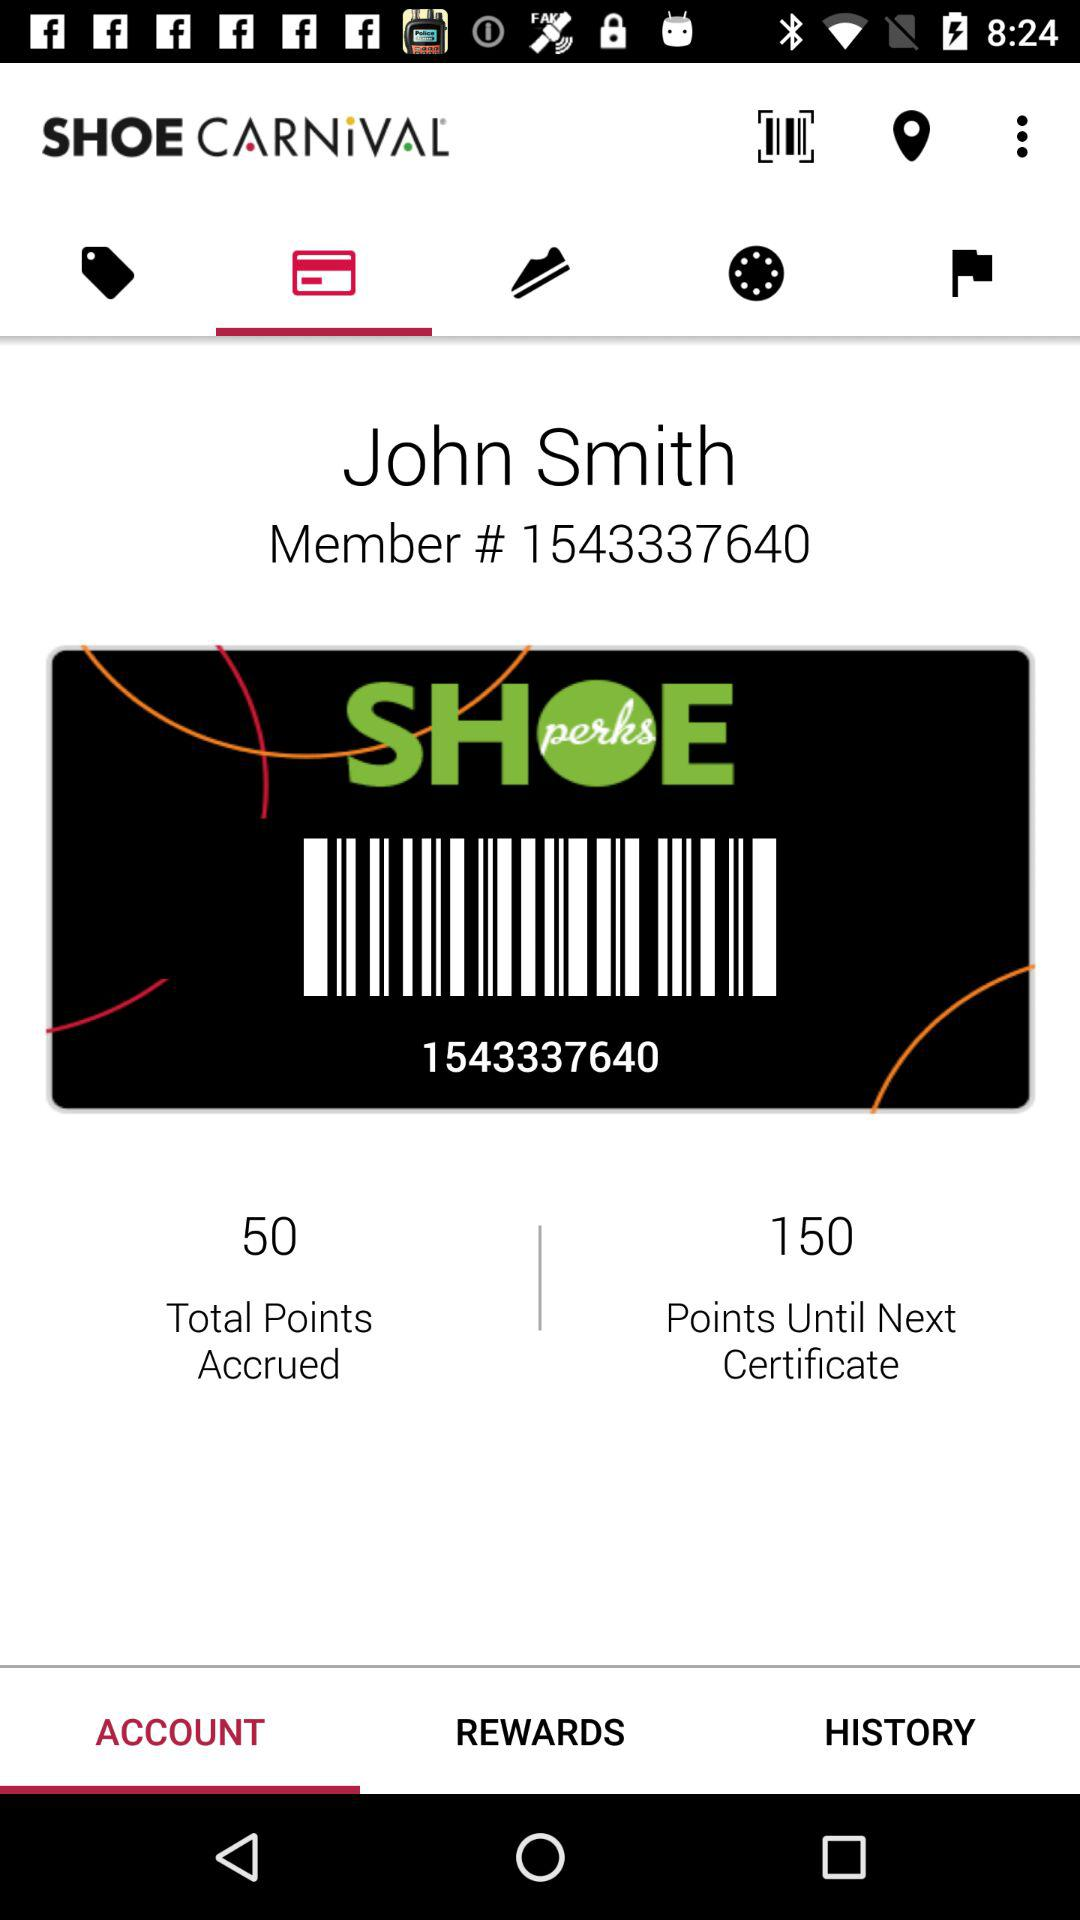What is the member ID? The member ID is 1543337640. 